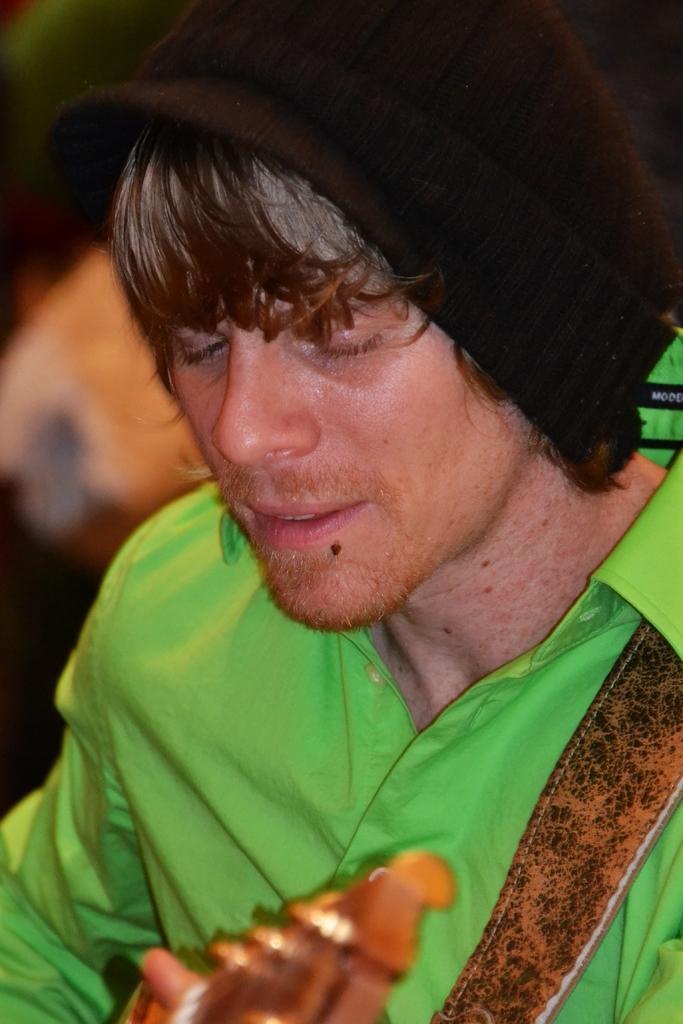Describe this image in one or two sentences. In this image there is a man in the center holding a musical instrument in his hand wearing a black colour hat. 